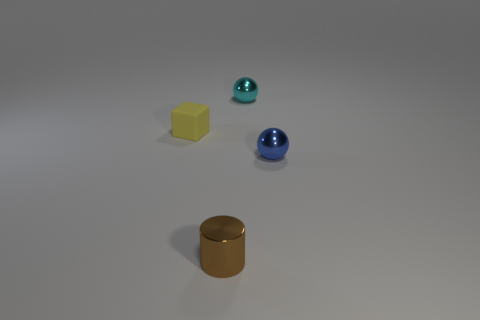What size is the cyan object that is the same shape as the blue metal thing?
Your answer should be compact. Small. What is the shape of the tiny object that is both left of the small cyan object and to the right of the yellow rubber thing?
Your answer should be compact. Cylinder. There is a yellow thing; is it the same size as the sphere that is in front of the yellow thing?
Give a very brief answer. Yes. What is the color of the other tiny thing that is the same shape as the tiny blue object?
Keep it short and to the point. Cyan. There is a thing that is to the left of the cylinder; is it the same size as the metal sphere on the right side of the cyan metallic thing?
Ensure brevity in your answer.  Yes. Does the blue shiny thing have the same shape as the small cyan object?
Provide a succinct answer. Yes. How many things are objects behind the tiny yellow rubber thing or tiny things?
Give a very brief answer. 4. Is there a cyan shiny thing of the same shape as the blue thing?
Your answer should be compact. Yes. Are there the same number of brown cylinders that are to the right of the brown cylinder and large green cylinders?
Offer a very short reply. Yes. What number of yellow matte things are the same size as the yellow rubber block?
Provide a succinct answer. 0. 